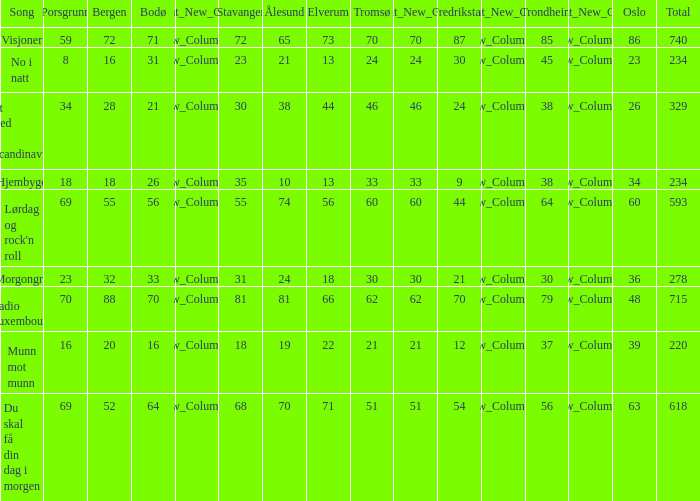When oslo is 48, what is stavanger? 81.0. Could you parse the entire table? {'header': ['Song', 'Porsgrunn', 'Bergen', 'Bodø', 'Relevant_New_Column1', 'Stavanger', 'Ålesund', 'Elverum', 'Tromsø', 'Relevant_New_Column2', 'Fredrikstad', 'Relevant_New_Column3', 'Trondheim', 'Relevant_New_Column4', 'Oslo', 'Total'], 'rows': [['Visjoner', '59', '72', '71', 'New_Column_1', '72', '65', '73', '70', '70', '87', 'New_Column_3', '85', 'New_Column_4', '86', '740'], ['No i natt', '8', '16', '31', 'New_Column_1', '23', '21', '13', '24', '24', '30', 'New_Column_3', '45', 'New_Column_4', '23', '234'], ['Et sted i Scandinavia', '34', '28', '21', 'New_Column_1', '30', '38', '44', '46', '46', '24', 'New_Column_3', '38', 'New_Column_4', '26', '329'], ['Hjembygd', '18', '18', '26', 'New_Column_1', '35', '10', '13', '33', '33', '9', 'New_Column_3', '38', 'New_Column_4', '34', '234'], ["Lørdag og rock'n roll", '69', '55', '56', 'New_Column_1', '55', '74', '56', '60', '60', '44', 'New_Column_3', '64', 'New_Column_4', '60', '593'], ['Morgongry', '23', '32', '33', 'New_Column_1', '31', '24', '18', '30', '30', '21', 'New_Column_3', '30', 'New_Column_4', '36', '278'], ['Radio Luxembourg', '70', '88', '70', 'New_Column_1', '81', '81', '66', '62', '62', '70', 'New_Column_3', '79', 'New_Column_4', '48', '715'], ['Munn mot munn', '16', '20', '16', 'New_Column_1', '18', '19', '22', '21', '21', '12', 'New_Column_3', '37', 'New_Column_4', '39', '220'], ['Du skal få din dag i morgen', '69', '52', '64', 'New_Column_1', '68', '70', '71', '51', '51', '54', 'New_Column_3', '56', 'New_Column_4', '63', '618']]} 